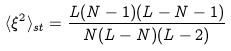Convert formula to latex. <formula><loc_0><loc_0><loc_500><loc_500>\langle \xi ^ { 2 } \rangle _ { s t } = \frac { L ( N - 1 ) ( L - N - 1 ) } { N ( L - N ) ( L - 2 ) }</formula> 